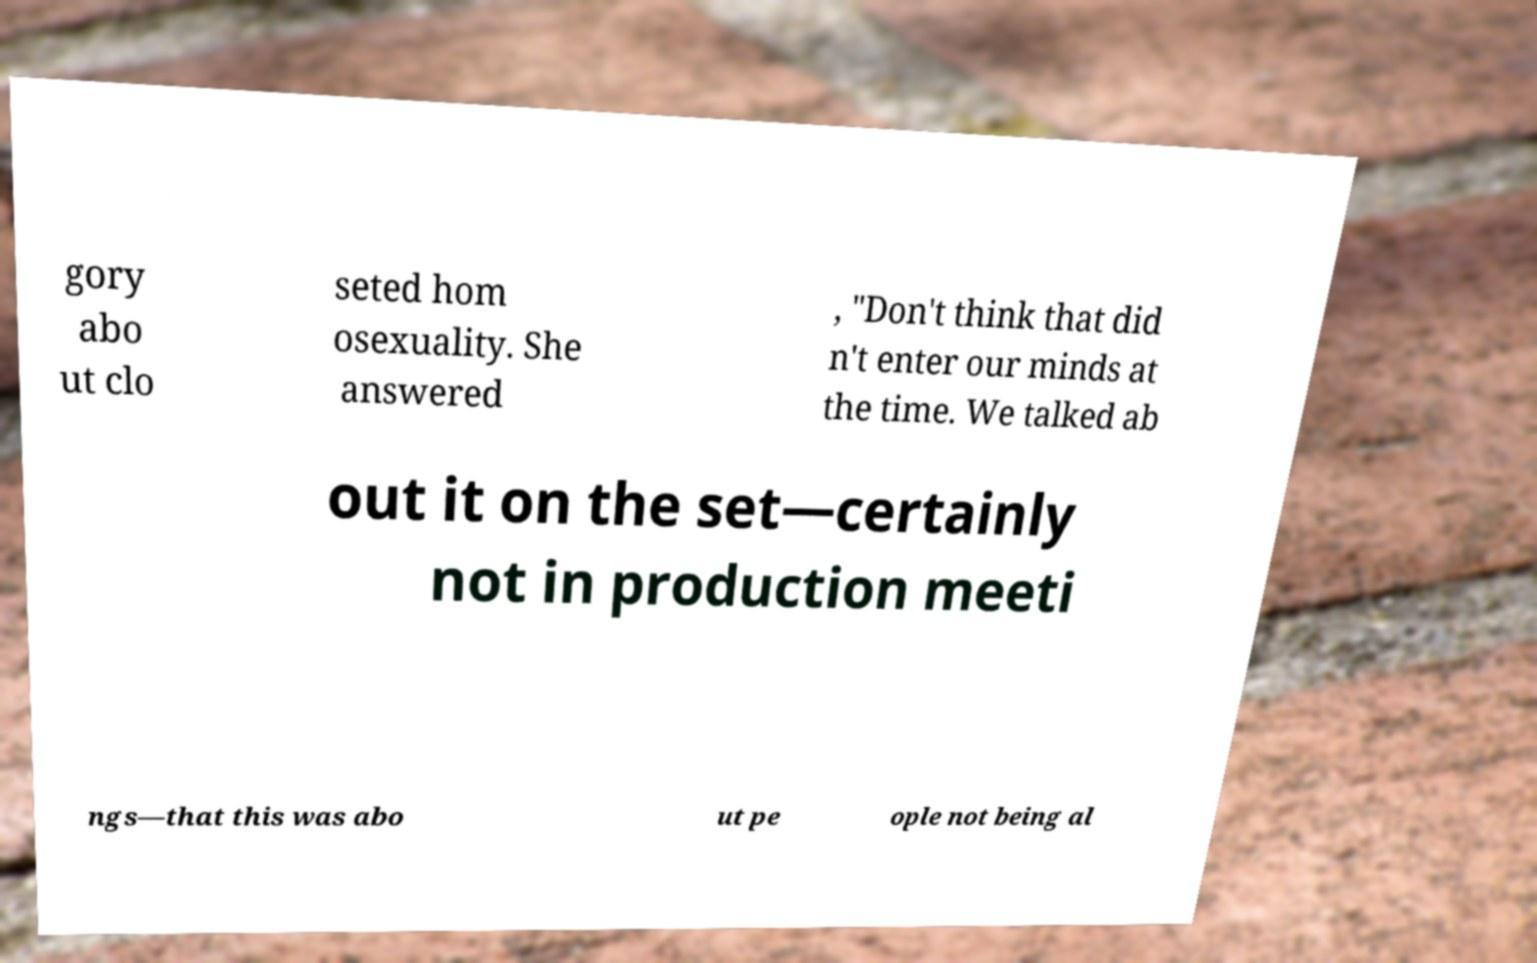What messages or text are displayed in this image? I need them in a readable, typed format. gory abo ut clo seted hom osexuality. She answered , "Don't think that did n't enter our minds at the time. We talked ab out it on the set—certainly not in production meeti ngs—that this was abo ut pe ople not being al 